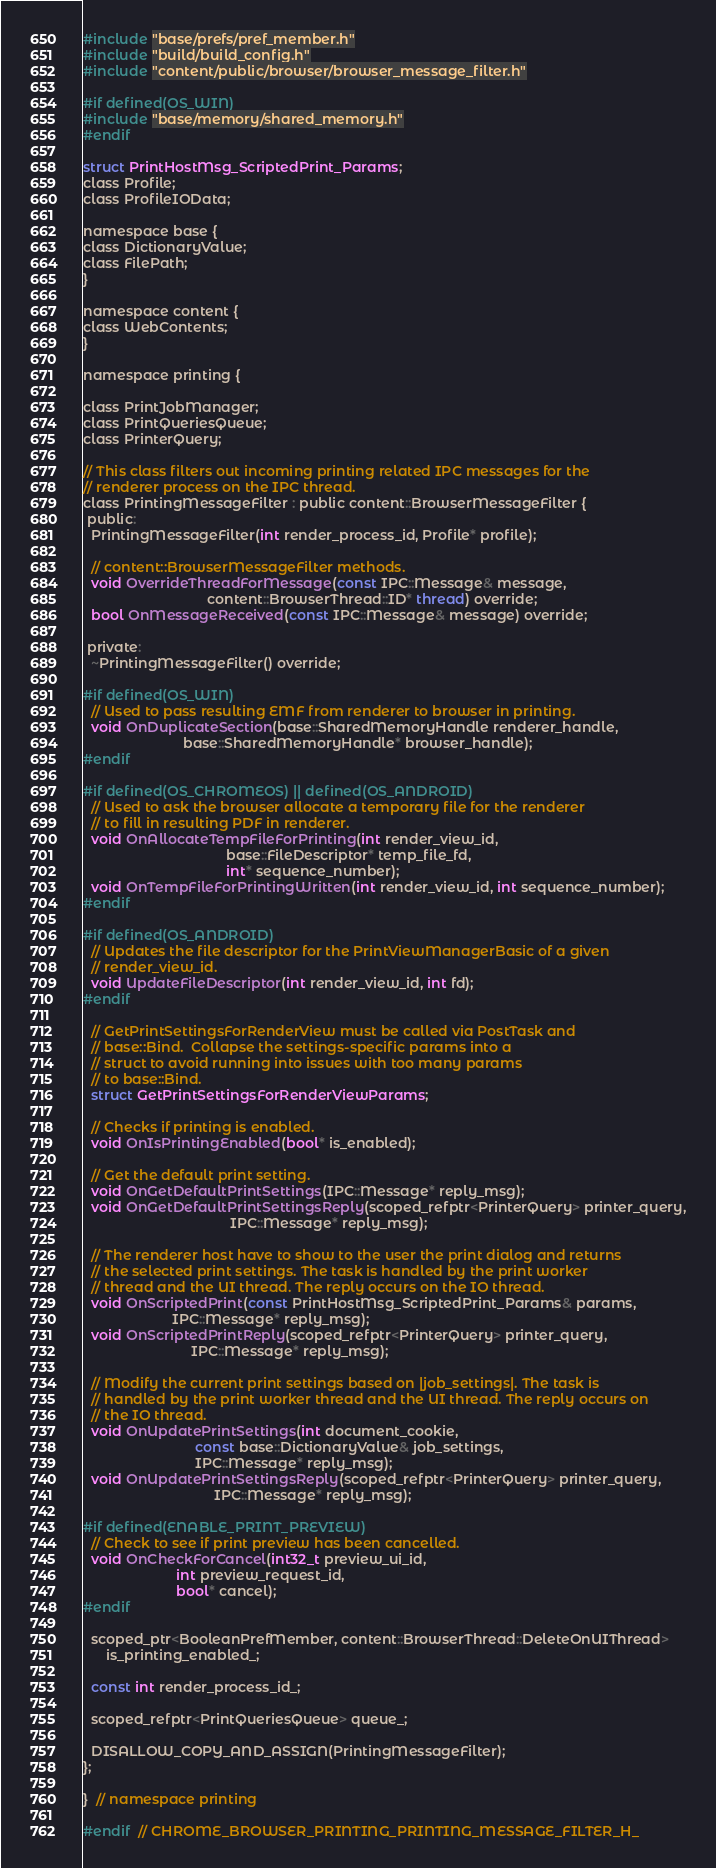Convert code to text. <code><loc_0><loc_0><loc_500><loc_500><_C_>#include "base/prefs/pref_member.h"
#include "build/build_config.h"
#include "content/public/browser/browser_message_filter.h"

#if defined(OS_WIN)
#include "base/memory/shared_memory.h"
#endif

struct PrintHostMsg_ScriptedPrint_Params;
class Profile;
class ProfileIOData;

namespace base {
class DictionaryValue;
class FilePath;
}

namespace content {
class WebContents;
}

namespace printing {

class PrintJobManager;
class PrintQueriesQueue;
class PrinterQuery;

// This class filters out incoming printing related IPC messages for the
// renderer process on the IPC thread.
class PrintingMessageFilter : public content::BrowserMessageFilter {
 public:
  PrintingMessageFilter(int render_process_id, Profile* profile);

  // content::BrowserMessageFilter methods.
  void OverrideThreadForMessage(const IPC::Message& message,
                                content::BrowserThread::ID* thread) override;
  bool OnMessageReceived(const IPC::Message& message) override;

 private:
  ~PrintingMessageFilter() override;

#if defined(OS_WIN)
  // Used to pass resulting EMF from renderer to browser in printing.
  void OnDuplicateSection(base::SharedMemoryHandle renderer_handle,
                          base::SharedMemoryHandle* browser_handle);
#endif

#if defined(OS_CHROMEOS) || defined(OS_ANDROID)
  // Used to ask the browser allocate a temporary file for the renderer
  // to fill in resulting PDF in renderer.
  void OnAllocateTempFileForPrinting(int render_view_id,
                                     base::FileDescriptor* temp_file_fd,
                                     int* sequence_number);
  void OnTempFileForPrintingWritten(int render_view_id, int sequence_number);
#endif

#if defined(OS_ANDROID)
  // Updates the file descriptor for the PrintViewManagerBasic of a given
  // render_view_id.
  void UpdateFileDescriptor(int render_view_id, int fd);
#endif

  // GetPrintSettingsForRenderView must be called via PostTask and
  // base::Bind.  Collapse the settings-specific params into a
  // struct to avoid running into issues with too many params
  // to base::Bind.
  struct GetPrintSettingsForRenderViewParams;

  // Checks if printing is enabled.
  void OnIsPrintingEnabled(bool* is_enabled);

  // Get the default print setting.
  void OnGetDefaultPrintSettings(IPC::Message* reply_msg);
  void OnGetDefaultPrintSettingsReply(scoped_refptr<PrinterQuery> printer_query,
                                      IPC::Message* reply_msg);

  // The renderer host have to show to the user the print dialog and returns
  // the selected print settings. The task is handled by the print worker
  // thread and the UI thread. The reply occurs on the IO thread.
  void OnScriptedPrint(const PrintHostMsg_ScriptedPrint_Params& params,
                       IPC::Message* reply_msg);
  void OnScriptedPrintReply(scoped_refptr<PrinterQuery> printer_query,
                            IPC::Message* reply_msg);

  // Modify the current print settings based on |job_settings|. The task is
  // handled by the print worker thread and the UI thread. The reply occurs on
  // the IO thread.
  void OnUpdatePrintSettings(int document_cookie,
                             const base::DictionaryValue& job_settings,
                             IPC::Message* reply_msg);
  void OnUpdatePrintSettingsReply(scoped_refptr<PrinterQuery> printer_query,
                                  IPC::Message* reply_msg);

#if defined(ENABLE_PRINT_PREVIEW)
  // Check to see if print preview has been cancelled.
  void OnCheckForCancel(int32_t preview_ui_id,
                        int preview_request_id,
                        bool* cancel);
#endif

  scoped_ptr<BooleanPrefMember, content::BrowserThread::DeleteOnUIThread>
      is_printing_enabled_;

  const int render_process_id_;

  scoped_refptr<PrintQueriesQueue> queue_;

  DISALLOW_COPY_AND_ASSIGN(PrintingMessageFilter);
};

}  // namespace printing

#endif  // CHROME_BROWSER_PRINTING_PRINTING_MESSAGE_FILTER_H_
</code> 